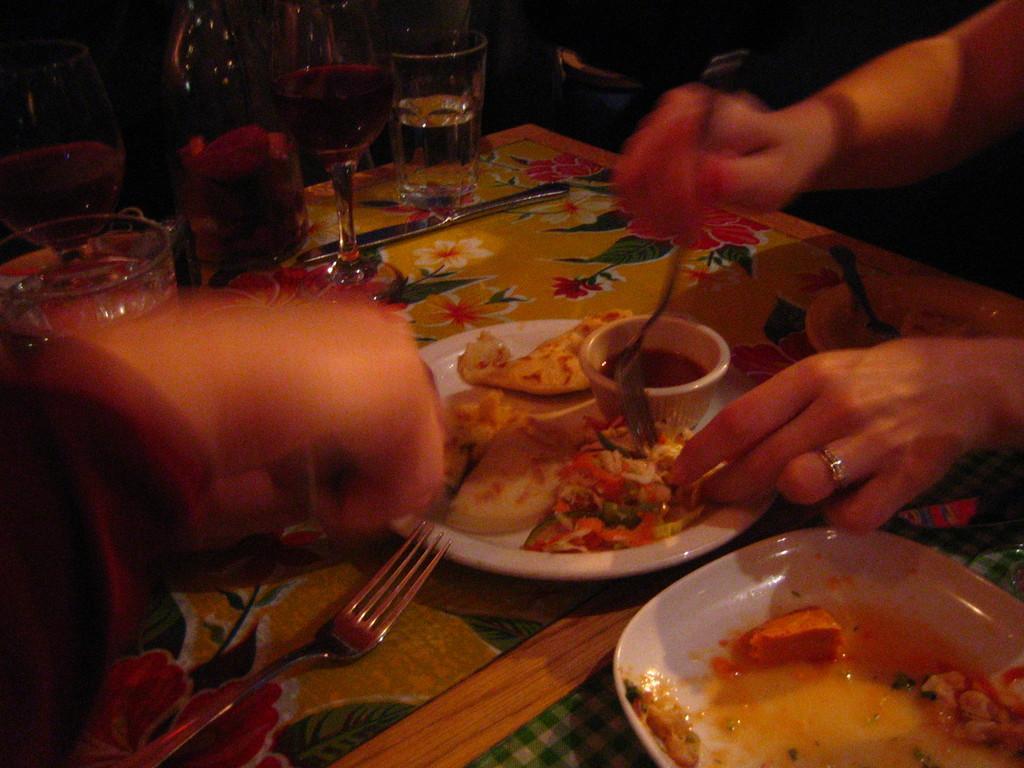Could you give a brief overview of what you see in this image? In this image I can see the table. On the table I can see the plates with food, bowl, glasses, knife and fork. I can see one person holding the fork. To the left I can see one more persons hand but it is blurry. And there is a black background. 